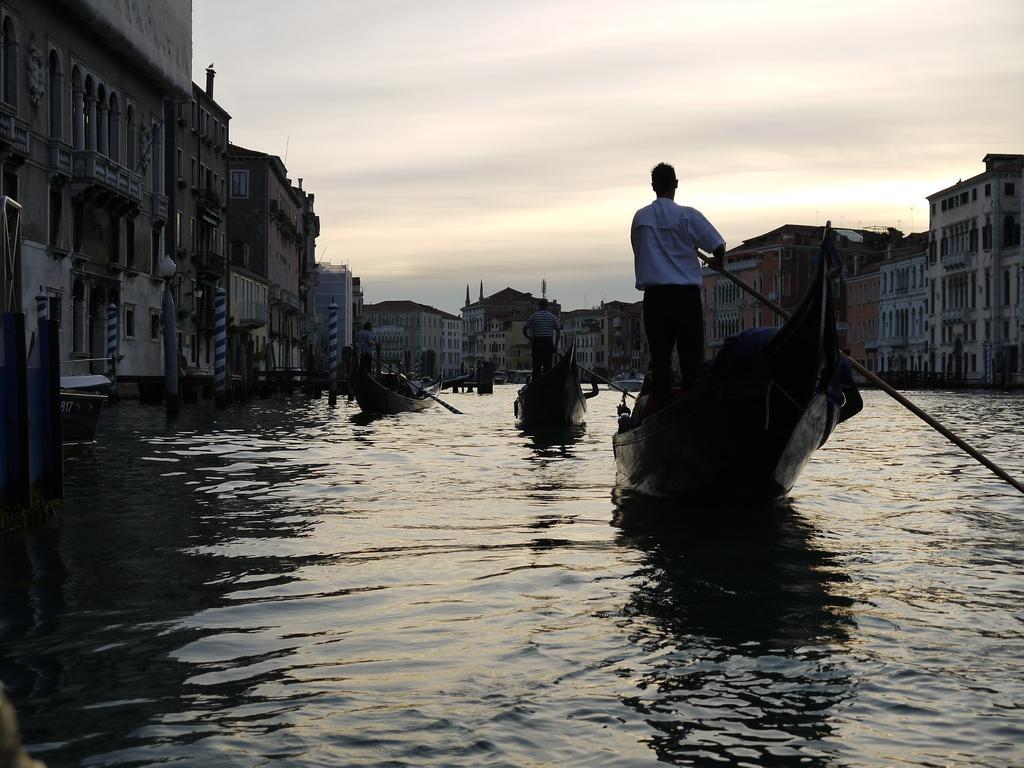Describe this image in one or two sentences. In this image we can see a few people on the boats, and holding paddles, there are buildings, windows, light pole and the water, also we can see the sky. 